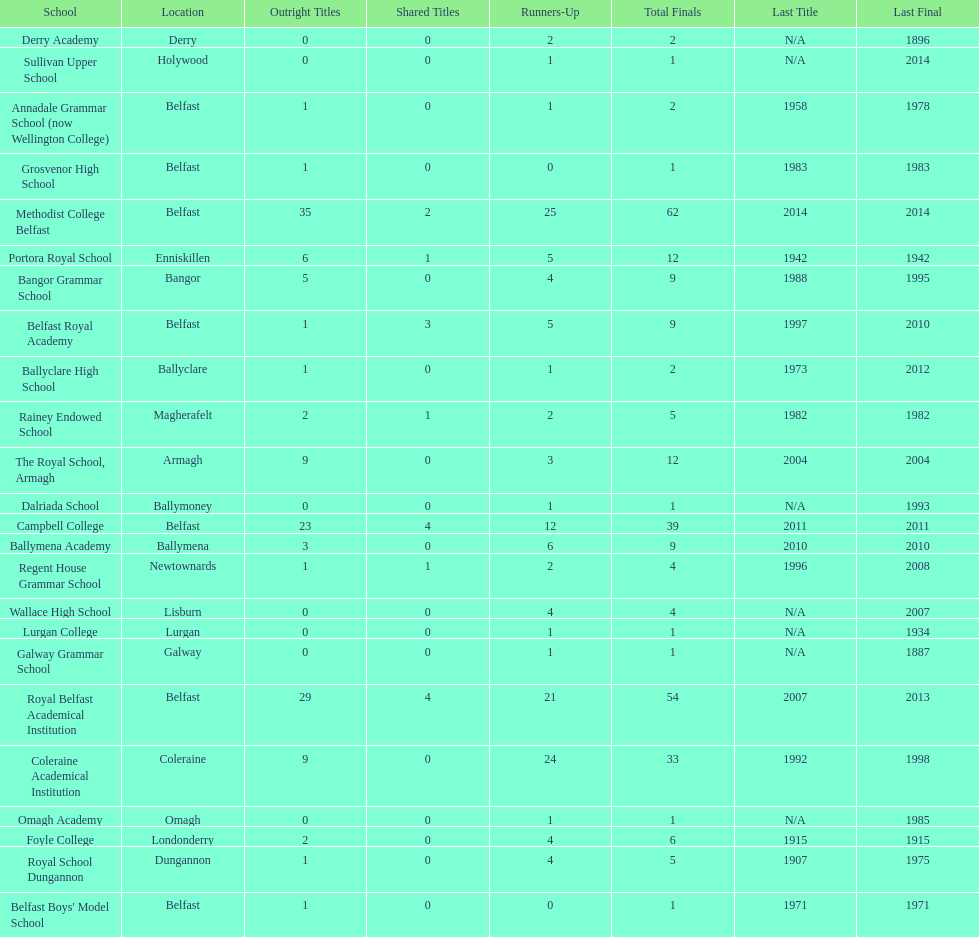How many schools had above 5 outright titles? 6. 